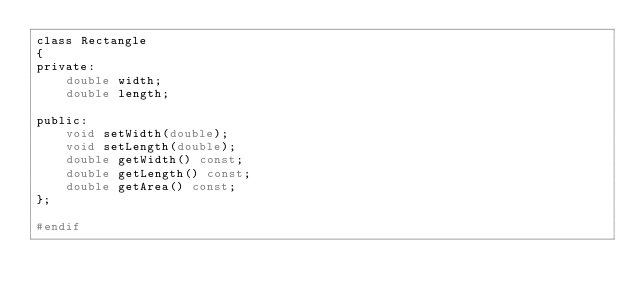<code> <loc_0><loc_0><loc_500><loc_500><_C_>class Rectangle
{
private:
    double width;
    double length;

public:
    void setWidth(double);
    void setLength(double);
    double getWidth() const;
    double getLength() const;
    double getArea() const;
};

#endif</code> 